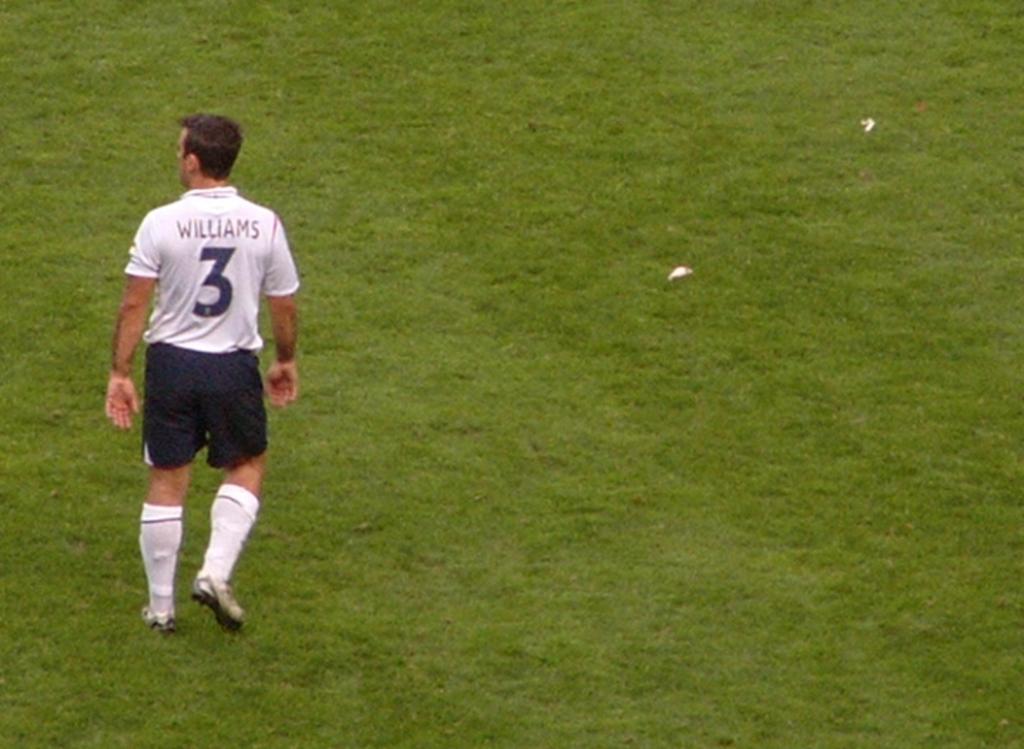What's his last name?
Keep it short and to the point. Williams. 